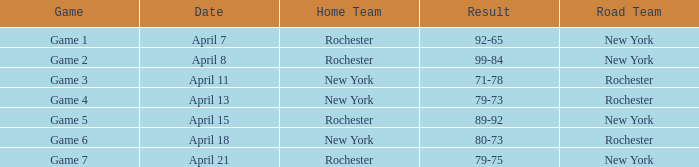Which Date has a Road Team of new york, and a Result of 79-75? April 21. 